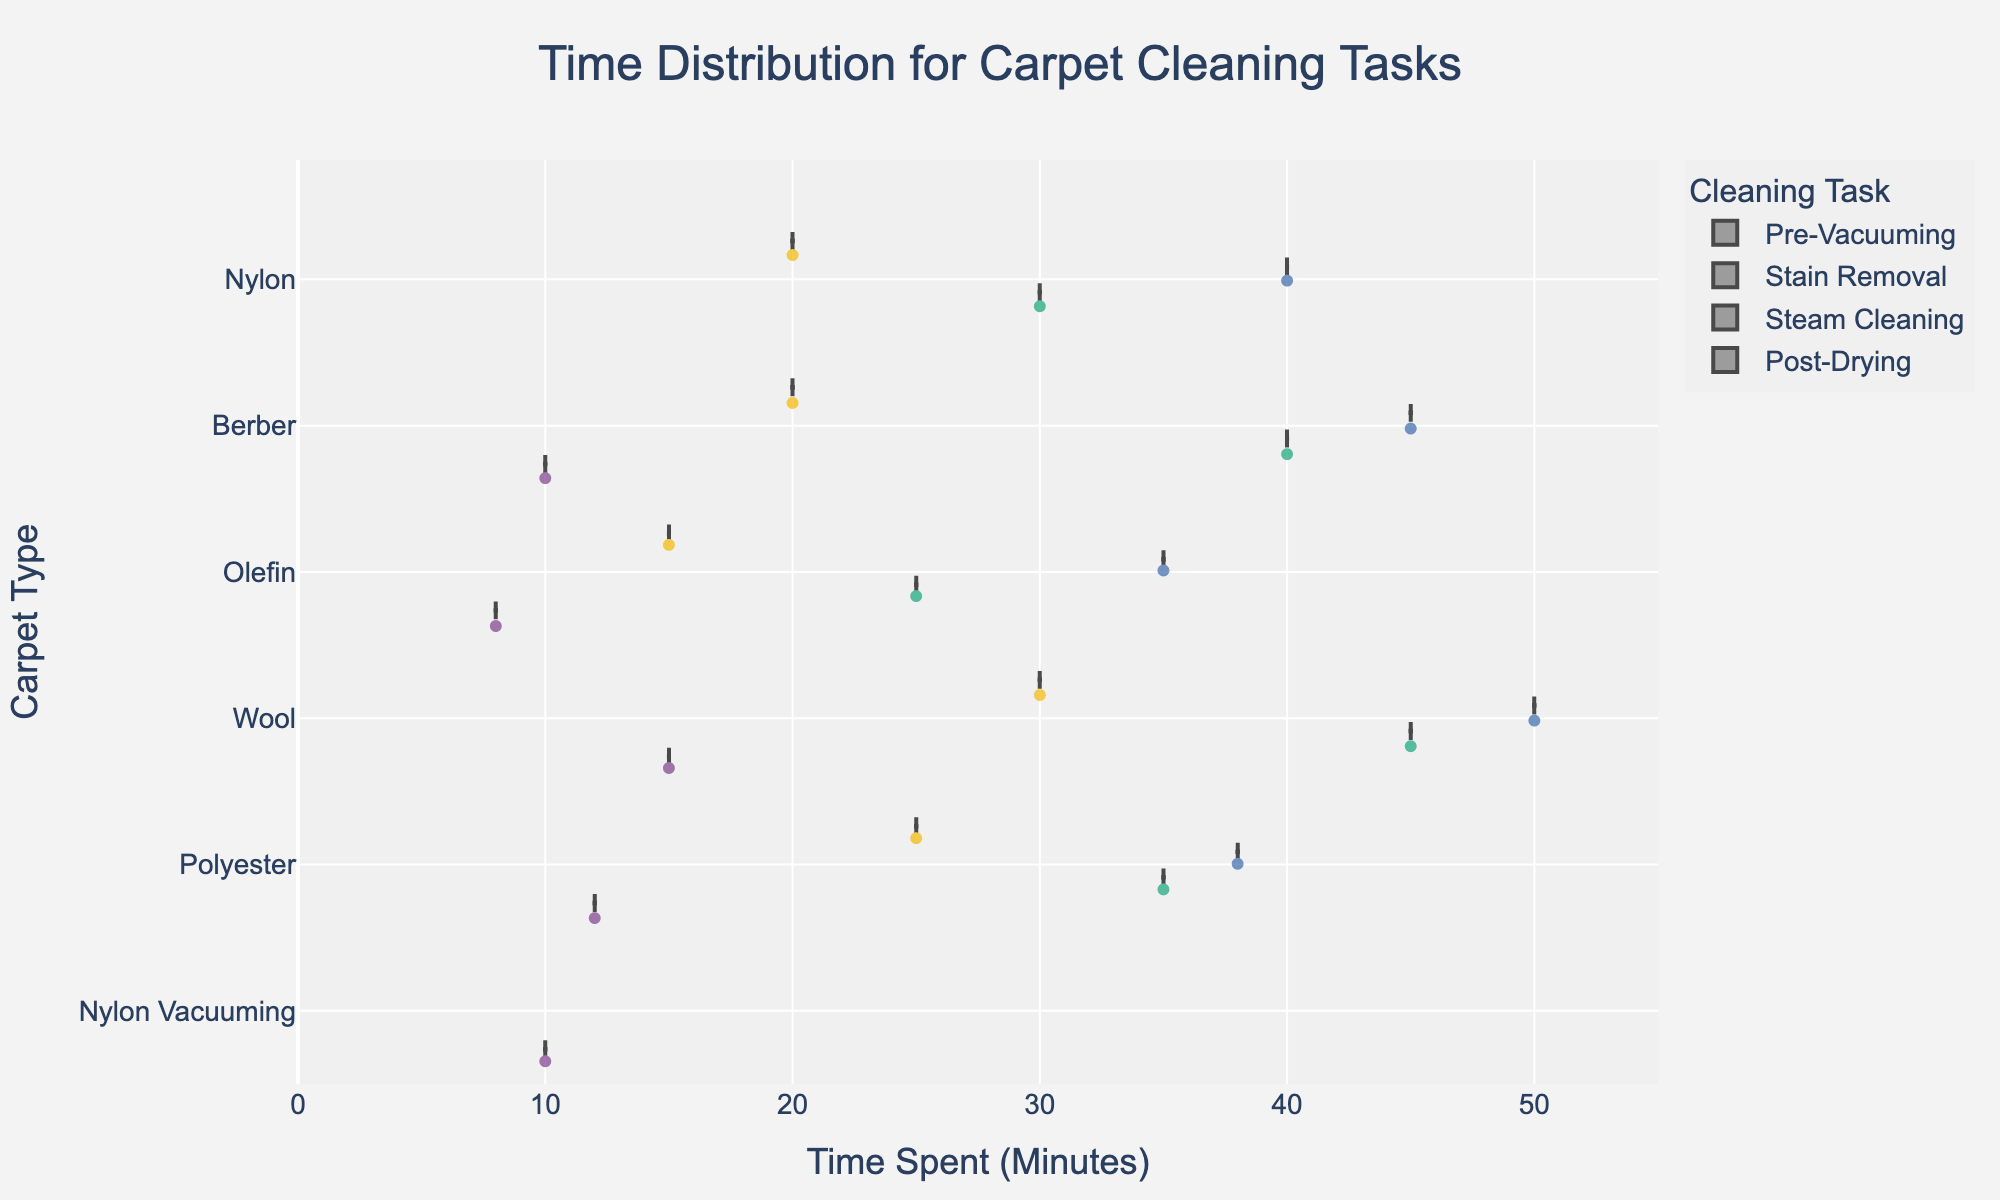What is the title of the chart? The title is usually positioned at the top of the chart for easy identification. In this case, it should describe what the chart is about.
Answer: Time Distribution for Carpet Cleaning Tasks Which task has the shortest time spent for Berber carpet? Berber carpet has various tasks represented. By looking at the horizontal position (time spent axis) of the violin plot colored for different tasks, we can see which task is the shortest.
Answer: Pre-Vacuuming What is the color used for the "Steam Cleaning" task? Each task is colored differently to distinguish it easily. Look for the legend, which matches colors to tasks.
Answer: One of the bold colors assigned in the chart How does the median time spent on "Post-Drying" compare across different carpet types? Each violin plot includes a box plot that marks the median. By noting the positions of these medians across different carpet types, we can compare them.
Answer: Higher for Wool, lower for Olefin and Nylon, moderate for others Which carpet type has the longest time spent for "Stain Removal"? The horizontal value (time spent) for "Stain Removal" has to be compared across all carpet types. The one with the highest value indicates the longest time.
Answer: Wool What is the range of times spent on "Steam Cleaning" across all carpet types? To find the range, identify the minimum and maximum times for "Steam Cleaning" across all carpet types using the furthest points on the violin plots' x-axis.
Answer: 35 to 50 minutes Which is more time-consuming on average for Polyester, "Stain Removal" or "Steam Cleaning"? For Polyester, compare the average (central tendency/median) times shown in the violin plots for "Stain Removal" and "Steam Cleaning". Determining which median is higher will answer this.
Answer: Stain Removal How evenly distributed is the time spent on "Pre-Vacuuming" compared to other tasks? Violin plots show the distribution of data points; a wider and more spread out violin indicates more variability. Compare the shape of "Pre-Vacuuming" violins to those of other tasks.
Answer: More evenly distributed Do any tasks have outliers, and which tasks are they? Outliers are often shown as individual points outside the main body of the violin plot. Look at the ends of the violins for any such points.
Answer: Check the violin tails for each task 